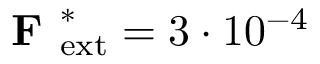Convert formula to latex. <formula><loc_0><loc_0><loc_500><loc_500>F _ { e x t } ^ { * } = 3 \cdot 1 0 ^ { - 4 }</formula> 